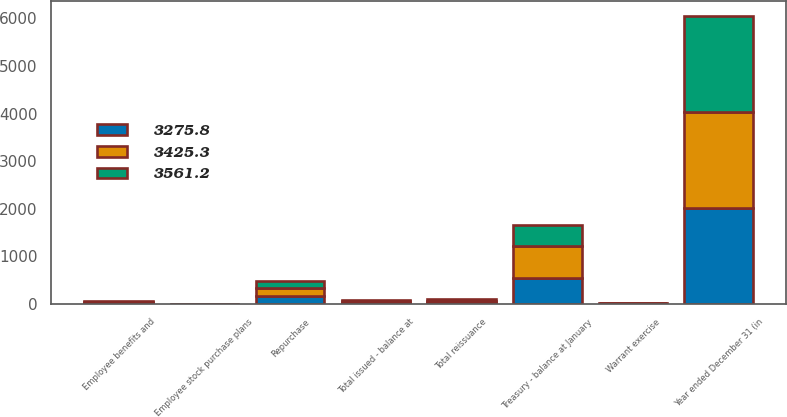Convert chart. <chart><loc_0><loc_0><loc_500><loc_500><stacked_bar_chart><ecel><fcel>Year ended December 31 (in<fcel>Total issued - balance at<fcel>Treasury - balance at January<fcel>Repurchase<fcel>Employee benefits and<fcel>Warrant exercise<fcel>Employee stock purchase plans<fcel>Total reissuance<nl><fcel>3425.3<fcel>2018<fcel>32<fcel>679.6<fcel>181.5<fcel>21.7<fcel>9.4<fcel>0.9<fcel>32<nl><fcel>3275.8<fcel>2017<fcel>32<fcel>543.7<fcel>166.6<fcel>24.5<fcel>5.4<fcel>0.8<fcel>30.7<nl><fcel>3561.2<fcel>2016<fcel>32<fcel>441.4<fcel>140.4<fcel>26<fcel>11.1<fcel>1<fcel>38.1<nl></chart> 